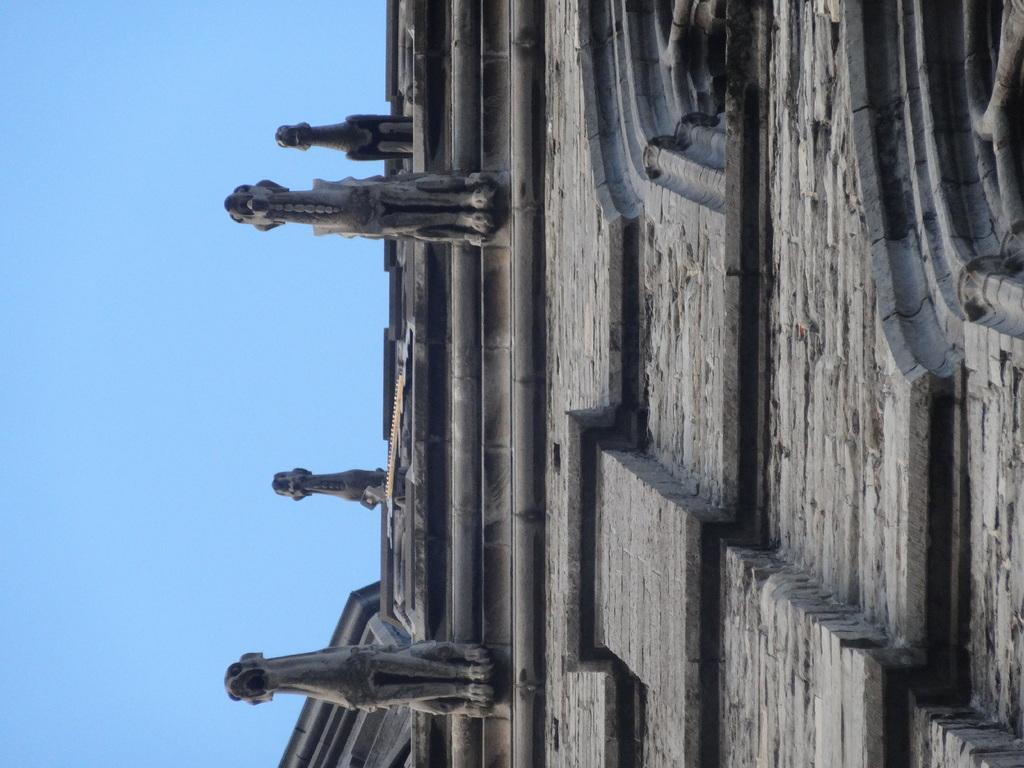What is the main subject of the image? The main subject of the image is a building. Are there any additional features on the building? Yes, there are sculptures attached to the building. What can be seen on the building besides the sculptures? There are windows on the building. What is visible in the background of the image? The sky is visible in the image. How much rice is being served in the image? There is no rice present in the image; it features a building with sculptures and windows. 